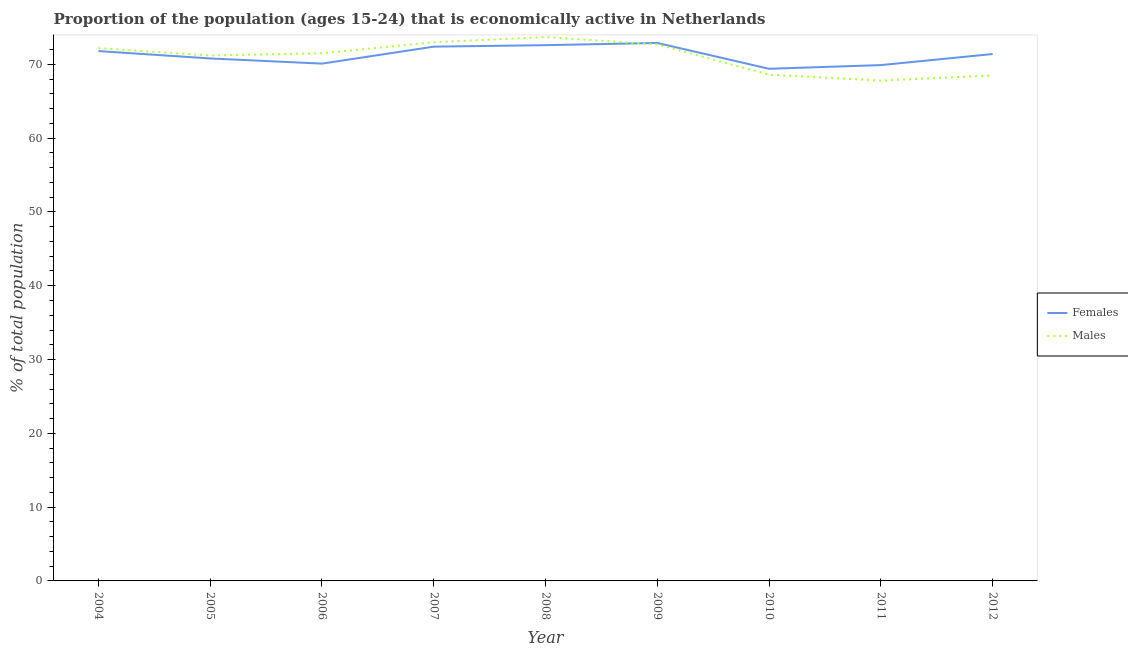Does the line corresponding to percentage of economically active female population intersect with the line corresponding to percentage of economically active male population?
Provide a succinct answer. Yes. Is the number of lines equal to the number of legend labels?
Offer a very short reply. Yes. What is the percentage of economically active male population in 2006?
Your answer should be compact. 71.5. Across all years, what is the maximum percentage of economically active male population?
Ensure brevity in your answer.  73.7. Across all years, what is the minimum percentage of economically active male population?
Make the answer very short. 67.8. In which year was the percentage of economically active female population minimum?
Give a very brief answer. 2010. What is the total percentage of economically active male population in the graph?
Your response must be concise. 639.2. What is the difference between the percentage of economically active male population in 2008 and that in 2010?
Give a very brief answer. 5.1. What is the difference between the percentage of economically active male population in 2005 and the percentage of economically active female population in 2008?
Your answer should be very brief. -1.4. What is the average percentage of economically active male population per year?
Make the answer very short. 71.02. In the year 2004, what is the difference between the percentage of economically active female population and percentage of economically active male population?
Your answer should be compact. -0.4. In how many years, is the percentage of economically active male population greater than 34 %?
Your answer should be compact. 9. What is the ratio of the percentage of economically active female population in 2005 to that in 2008?
Provide a succinct answer. 0.98. What is the difference between the highest and the second highest percentage of economically active female population?
Your answer should be very brief. 0.3. What is the difference between the highest and the lowest percentage of economically active female population?
Offer a terse response. 3.5. In how many years, is the percentage of economically active female population greater than the average percentage of economically active female population taken over all years?
Your response must be concise. 5. Does the percentage of economically active female population monotonically increase over the years?
Offer a very short reply. No. Is the percentage of economically active female population strictly less than the percentage of economically active male population over the years?
Your answer should be very brief. No. What is the difference between two consecutive major ticks on the Y-axis?
Offer a terse response. 10. Does the graph contain grids?
Your answer should be compact. No. What is the title of the graph?
Provide a succinct answer. Proportion of the population (ages 15-24) that is economically active in Netherlands. What is the label or title of the Y-axis?
Your answer should be very brief. % of total population. What is the % of total population in Females in 2004?
Keep it short and to the point. 71.8. What is the % of total population of Males in 2004?
Make the answer very short. 72.2. What is the % of total population of Females in 2005?
Ensure brevity in your answer.  70.8. What is the % of total population in Males in 2005?
Keep it short and to the point. 71.2. What is the % of total population of Females in 2006?
Ensure brevity in your answer.  70.1. What is the % of total population in Males in 2006?
Offer a very short reply. 71.5. What is the % of total population in Females in 2007?
Offer a very short reply. 72.4. What is the % of total population in Females in 2008?
Provide a succinct answer. 72.6. What is the % of total population in Males in 2008?
Provide a short and direct response. 73.7. What is the % of total population of Females in 2009?
Your answer should be compact. 72.9. What is the % of total population in Males in 2009?
Your answer should be very brief. 72.7. What is the % of total population of Females in 2010?
Make the answer very short. 69.4. What is the % of total population of Males in 2010?
Ensure brevity in your answer.  68.6. What is the % of total population of Females in 2011?
Offer a very short reply. 69.9. What is the % of total population of Males in 2011?
Your response must be concise. 67.8. What is the % of total population in Females in 2012?
Make the answer very short. 71.4. What is the % of total population in Males in 2012?
Your answer should be very brief. 68.5. Across all years, what is the maximum % of total population in Females?
Keep it short and to the point. 72.9. Across all years, what is the maximum % of total population in Males?
Make the answer very short. 73.7. Across all years, what is the minimum % of total population in Females?
Ensure brevity in your answer.  69.4. Across all years, what is the minimum % of total population of Males?
Make the answer very short. 67.8. What is the total % of total population of Females in the graph?
Keep it short and to the point. 641.3. What is the total % of total population of Males in the graph?
Ensure brevity in your answer.  639.2. What is the difference between the % of total population of Males in 2004 and that in 2006?
Provide a succinct answer. 0.7. What is the difference between the % of total population in Females in 2004 and that in 2007?
Give a very brief answer. -0.6. What is the difference between the % of total population in Males in 2004 and that in 2007?
Provide a short and direct response. -0.8. What is the difference between the % of total population in Females in 2004 and that in 2008?
Offer a terse response. -0.8. What is the difference between the % of total population of Males in 2004 and that in 2009?
Offer a very short reply. -0.5. What is the difference between the % of total population in Females in 2004 and that in 2010?
Offer a terse response. 2.4. What is the difference between the % of total population of Males in 2004 and that in 2012?
Keep it short and to the point. 3.7. What is the difference between the % of total population of Females in 2005 and that in 2006?
Keep it short and to the point. 0.7. What is the difference between the % of total population of Females in 2005 and that in 2007?
Provide a succinct answer. -1.6. What is the difference between the % of total population of Males in 2005 and that in 2007?
Ensure brevity in your answer.  -1.8. What is the difference between the % of total population of Males in 2005 and that in 2008?
Provide a short and direct response. -2.5. What is the difference between the % of total population of Females in 2005 and that in 2009?
Your response must be concise. -2.1. What is the difference between the % of total population in Males in 2005 and that in 2010?
Offer a terse response. 2.6. What is the difference between the % of total population of Females in 2005 and that in 2011?
Your answer should be compact. 0.9. What is the difference between the % of total population of Females in 2006 and that in 2007?
Offer a terse response. -2.3. What is the difference between the % of total population in Males in 2006 and that in 2007?
Your response must be concise. -1.5. What is the difference between the % of total population in Males in 2006 and that in 2012?
Your response must be concise. 3. What is the difference between the % of total population of Females in 2007 and that in 2008?
Offer a very short reply. -0.2. What is the difference between the % of total population of Males in 2007 and that in 2009?
Keep it short and to the point. 0.3. What is the difference between the % of total population in Males in 2007 and that in 2010?
Provide a short and direct response. 4.4. What is the difference between the % of total population of Females in 2007 and that in 2012?
Offer a very short reply. 1. What is the difference between the % of total population of Males in 2007 and that in 2012?
Your answer should be compact. 4.5. What is the difference between the % of total population in Females in 2008 and that in 2009?
Offer a very short reply. -0.3. What is the difference between the % of total population in Males in 2008 and that in 2009?
Provide a succinct answer. 1. What is the difference between the % of total population in Females in 2008 and that in 2010?
Ensure brevity in your answer.  3.2. What is the difference between the % of total population of Females in 2008 and that in 2011?
Provide a short and direct response. 2.7. What is the difference between the % of total population of Males in 2008 and that in 2011?
Offer a very short reply. 5.9. What is the difference between the % of total population in Females in 2008 and that in 2012?
Your response must be concise. 1.2. What is the difference between the % of total population in Males in 2009 and that in 2010?
Keep it short and to the point. 4.1. What is the difference between the % of total population in Females in 2009 and that in 2011?
Offer a very short reply. 3. What is the difference between the % of total population of Males in 2009 and that in 2011?
Give a very brief answer. 4.9. What is the difference between the % of total population in Females in 2009 and that in 2012?
Your answer should be very brief. 1.5. What is the difference between the % of total population of Males in 2009 and that in 2012?
Offer a very short reply. 4.2. What is the difference between the % of total population in Females in 2010 and that in 2011?
Offer a very short reply. -0.5. What is the difference between the % of total population in Males in 2011 and that in 2012?
Keep it short and to the point. -0.7. What is the difference between the % of total population of Females in 2004 and the % of total population of Males in 2005?
Your response must be concise. 0.6. What is the difference between the % of total population of Females in 2004 and the % of total population of Males in 2006?
Keep it short and to the point. 0.3. What is the difference between the % of total population of Females in 2004 and the % of total population of Males in 2007?
Your response must be concise. -1.2. What is the difference between the % of total population of Females in 2004 and the % of total population of Males in 2008?
Give a very brief answer. -1.9. What is the difference between the % of total population of Females in 2004 and the % of total population of Males in 2011?
Your response must be concise. 4. What is the difference between the % of total population in Females in 2004 and the % of total population in Males in 2012?
Give a very brief answer. 3.3. What is the difference between the % of total population of Females in 2005 and the % of total population of Males in 2007?
Offer a terse response. -2.2. What is the difference between the % of total population in Females in 2005 and the % of total population in Males in 2011?
Keep it short and to the point. 3. What is the difference between the % of total population in Females in 2006 and the % of total population in Males in 2007?
Provide a succinct answer. -2.9. What is the difference between the % of total population in Females in 2006 and the % of total population in Males in 2009?
Give a very brief answer. -2.6. What is the difference between the % of total population of Females in 2007 and the % of total population of Males in 2008?
Provide a succinct answer. -1.3. What is the difference between the % of total population in Females in 2007 and the % of total population in Males in 2009?
Offer a terse response. -0.3. What is the difference between the % of total population in Females in 2007 and the % of total population in Males in 2011?
Offer a very short reply. 4.6. What is the difference between the % of total population in Females in 2008 and the % of total population in Males in 2009?
Make the answer very short. -0.1. What is the difference between the % of total population of Females in 2008 and the % of total population of Males in 2011?
Offer a very short reply. 4.8. What is the difference between the % of total population in Females in 2009 and the % of total population in Males in 2010?
Ensure brevity in your answer.  4.3. What is the difference between the % of total population of Females in 2009 and the % of total population of Males in 2012?
Make the answer very short. 4.4. What is the average % of total population in Females per year?
Your answer should be compact. 71.26. What is the average % of total population in Males per year?
Make the answer very short. 71.02. In the year 2004, what is the difference between the % of total population in Females and % of total population in Males?
Your response must be concise. -0.4. In the year 2006, what is the difference between the % of total population of Females and % of total population of Males?
Ensure brevity in your answer.  -1.4. In the year 2007, what is the difference between the % of total population of Females and % of total population of Males?
Your answer should be compact. -0.6. In the year 2009, what is the difference between the % of total population in Females and % of total population in Males?
Keep it short and to the point. 0.2. In the year 2012, what is the difference between the % of total population in Females and % of total population in Males?
Give a very brief answer. 2.9. What is the ratio of the % of total population of Females in 2004 to that in 2005?
Your response must be concise. 1.01. What is the ratio of the % of total population in Males in 2004 to that in 2005?
Ensure brevity in your answer.  1.01. What is the ratio of the % of total population in Females in 2004 to that in 2006?
Your answer should be very brief. 1.02. What is the ratio of the % of total population of Males in 2004 to that in 2006?
Provide a succinct answer. 1.01. What is the ratio of the % of total population of Males in 2004 to that in 2008?
Make the answer very short. 0.98. What is the ratio of the % of total population in Females in 2004 to that in 2009?
Make the answer very short. 0.98. What is the ratio of the % of total population in Males in 2004 to that in 2009?
Provide a succinct answer. 0.99. What is the ratio of the % of total population in Females in 2004 to that in 2010?
Your answer should be compact. 1.03. What is the ratio of the % of total population in Males in 2004 to that in 2010?
Make the answer very short. 1.05. What is the ratio of the % of total population in Females in 2004 to that in 2011?
Keep it short and to the point. 1.03. What is the ratio of the % of total population in Males in 2004 to that in 2011?
Ensure brevity in your answer.  1.06. What is the ratio of the % of total population of Females in 2004 to that in 2012?
Ensure brevity in your answer.  1.01. What is the ratio of the % of total population of Males in 2004 to that in 2012?
Ensure brevity in your answer.  1.05. What is the ratio of the % of total population of Males in 2005 to that in 2006?
Offer a very short reply. 1. What is the ratio of the % of total population in Females in 2005 to that in 2007?
Offer a very short reply. 0.98. What is the ratio of the % of total population of Males in 2005 to that in 2007?
Your answer should be compact. 0.98. What is the ratio of the % of total population in Females in 2005 to that in 2008?
Offer a very short reply. 0.98. What is the ratio of the % of total population in Males in 2005 to that in 2008?
Keep it short and to the point. 0.97. What is the ratio of the % of total population of Females in 2005 to that in 2009?
Your response must be concise. 0.97. What is the ratio of the % of total population of Males in 2005 to that in 2009?
Your answer should be very brief. 0.98. What is the ratio of the % of total population of Females in 2005 to that in 2010?
Ensure brevity in your answer.  1.02. What is the ratio of the % of total population in Males in 2005 to that in 2010?
Your answer should be compact. 1.04. What is the ratio of the % of total population in Females in 2005 to that in 2011?
Your answer should be very brief. 1.01. What is the ratio of the % of total population in Males in 2005 to that in 2011?
Your response must be concise. 1.05. What is the ratio of the % of total population in Females in 2005 to that in 2012?
Make the answer very short. 0.99. What is the ratio of the % of total population of Males in 2005 to that in 2012?
Your answer should be very brief. 1.04. What is the ratio of the % of total population in Females in 2006 to that in 2007?
Offer a terse response. 0.97. What is the ratio of the % of total population of Males in 2006 to that in 2007?
Offer a terse response. 0.98. What is the ratio of the % of total population of Females in 2006 to that in 2008?
Make the answer very short. 0.97. What is the ratio of the % of total population in Males in 2006 to that in 2008?
Offer a terse response. 0.97. What is the ratio of the % of total population of Females in 2006 to that in 2009?
Your answer should be compact. 0.96. What is the ratio of the % of total population of Males in 2006 to that in 2009?
Offer a very short reply. 0.98. What is the ratio of the % of total population of Males in 2006 to that in 2010?
Offer a very short reply. 1.04. What is the ratio of the % of total population of Females in 2006 to that in 2011?
Offer a very short reply. 1. What is the ratio of the % of total population of Males in 2006 to that in 2011?
Ensure brevity in your answer.  1.05. What is the ratio of the % of total population of Females in 2006 to that in 2012?
Ensure brevity in your answer.  0.98. What is the ratio of the % of total population in Males in 2006 to that in 2012?
Offer a very short reply. 1.04. What is the ratio of the % of total population of Males in 2007 to that in 2008?
Give a very brief answer. 0.99. What is the ratio of the % of total population in Females in 2007 to that in 2009?
Your answer should be very brief. 0.99. What is the ratio of the % of total population of Females in 2007 to that in 2010?
Give a very brief answer. 1.04. What is the ratio of the % of total population in Males in 2007 to that in 2010?
Make the answer very short. 1.06. What is the ratio of the % of total population in Females in 2007 to that in 2011?
Offer a terse response. 1.04. What is the ratio of the % of total population of Males in 2007 to that in 2011?
Provide a short and direct response. 1.08. What is the ratio of the % of total population in Females in 2007 to that in 2012?
Make the answer very short. 1.01. What is the ratio of the % of total population of Males in 2007 to that in 2012?
Your response must be concise. 1.07. What is the ratio of the % of total population in Males in 2008 to that in 2009?
Give a very brief answer. 1.01. What is the ratio of the % of total population in Females in 2008 to that in 2010?
Give a very brief answer. 1.05. What is the ratio of the % of total population in Males in 2008 to that in 2010?
Your answer should be compact. 1.07. What is the ratio of the % of total population in Females in 2008 to that in 2011?
Make the answer very short. 1.04. What is the ratio of the % of total population of Males in 2008 to that in 2011?
Ensure brevity in your answer.  1.09. What is the ratio of the % of total population in Females in 2008 to that in 2012?
Offer a very short reply. 1.02. What is the ratio of the % of total population in Males in 2008 to that in 2012?
Offer a terse response. 1.08. What is the ratio of the % of total population of Females in 2009 to that in 2010?
Keep it short and to the point. 1.05. What is the ratio of the % of total population of Males in 2009 to that in 2010?
Provide a succinct answer. 1.06. What is the ratio of the % of total population of Females in 2009 to that in 2011?
Your response must be concise. 1.04. What is the ratio of the % of total population of Males in 2009 to that in 2011?
Ensure brevity in your answer.  1.07. What is the ratio of the % of total population in Males in 2009 to that in 2012?
Your answer should be very brief. 1.06. What is the ratio of the % of total population in Males in 2010 to that in 2011?
Offer a very short reply. 1.01. What is the ratio of the % of total population in Females in 2010 to that in 2012?
Keep it short and to the point. 0.97. What is the ratio of the % of total population of Males in 2011 to that in 2012?
Keep it short and to the point. 0.99. What is the difference between the highest and the second highest % of total population in Females?
Provide a short and direct response. 0.3. What is the difference between the highest and the second highest % of total population of Males?
Provide a short and direct response. 0.7. What is the difference between the highest and the lowest % of total population of Females?
Your answer should be very brief. 3.5. 